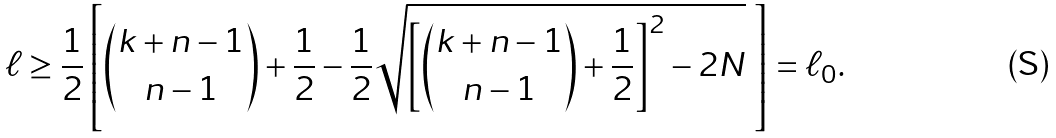Convert formula to latex. <formula><loc_0><loc_0><loc_500><loc_500>\ell \geq \frac { 1 } { 2 } \left [ \binom { k + n - 1 } { n - 1 } + \frac { 1 } { 2 } - \frac { 1 } { 2 } \sqrt { \left [ \binom { k + n - 1 } { n - 1 } + \frac { 1 } { 2 } \right ] ^ { 2 } - 2 N } \ \right ] = \ell _ { 0 } .</formula> 